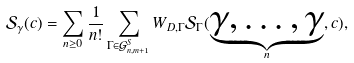<formula> <loc_0><loc_0><loc_500><loc_500>\mathcal { S } _ { \gamma } ( c ) = \sum _ { n \geq 0 } \frac { 1 } { n ! } \sum _ { \Gamma \in \mathcal { G } _ { n , m + 1 } ^ { S } } W _ { D , \Gamma } \mathcal { S } _ { \Gamma } ( \underset { n } { \underbrace { \gamma , \dots , \gamma } } , c ) ,</formula> 